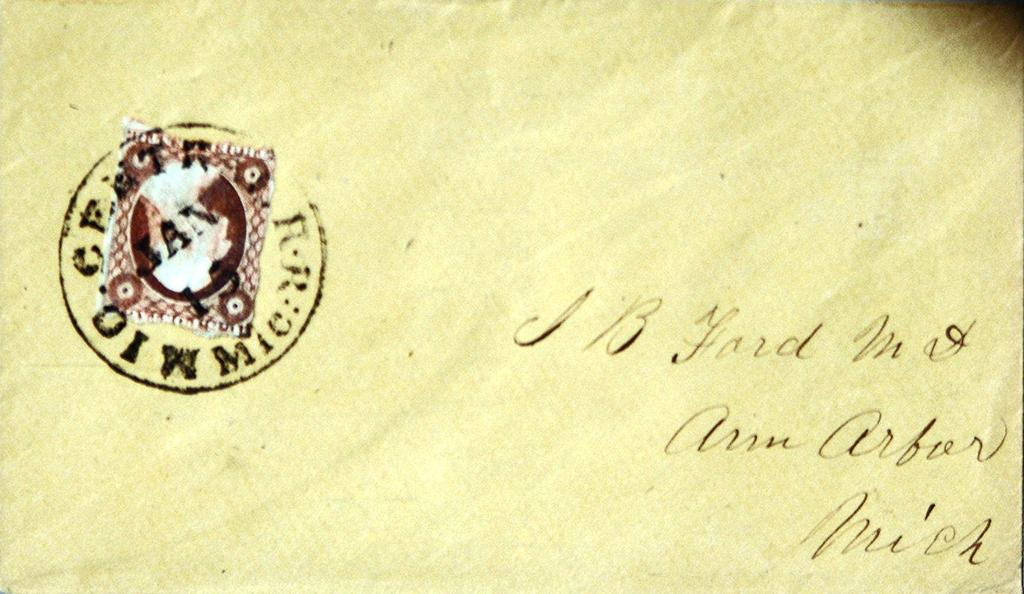<image>
Render a clear and concise summary of the photo. An envelope is addressed to someone in Ann Arbor, Michigan. 